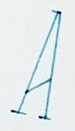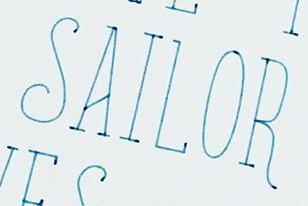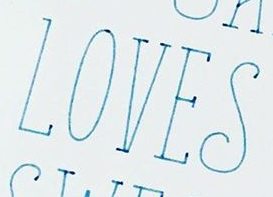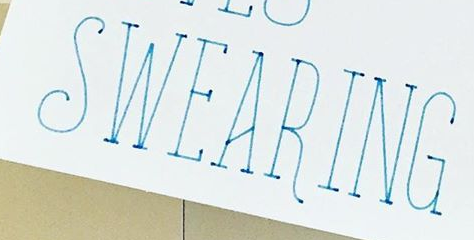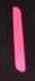Transcribe the words shown in these images in order, separated by a semicolon. A; SAILOR; LOVES; SWEARING; I 